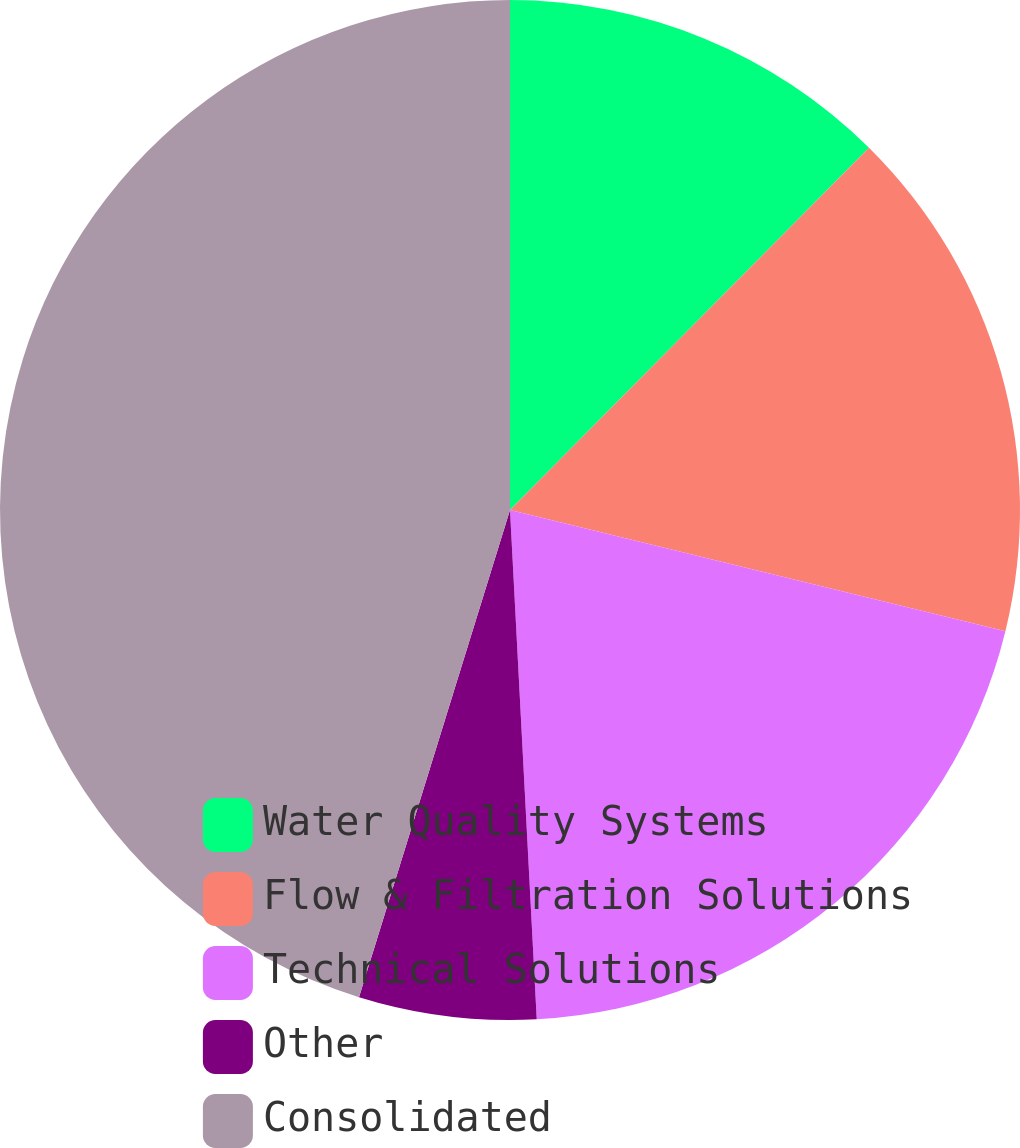Convert chart to OTSL. <chart><loc_0><loc_0><loc_500><loc_500><pie_chart><fcel>Water Quality Systems<fcel>Flow & Filtration Solutions<fcel>Technical Solutions<fcel>Other<fcel>Consolidated<nl><fcel>12.43%<fcel>16.39%<fcel>20.35%<fcel>5.62%<fcel>45.22%<nl></chart> 